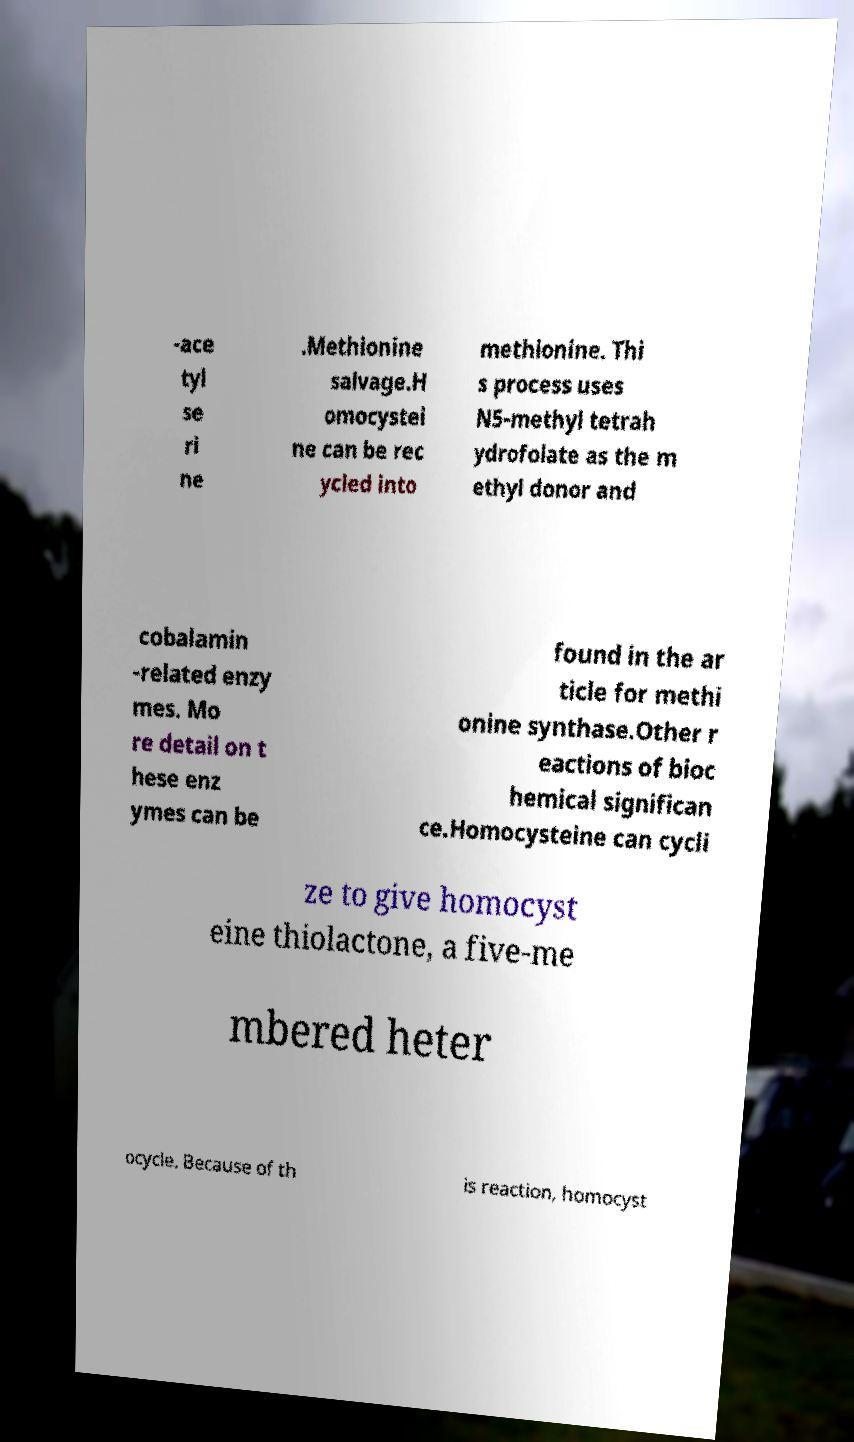Could you extract and type out the text from this image? -ace tyl se ri ne .Methionine salvage.H omocystei ne can be rec ycled into methionine. Thi s process uses N5-methyl tetrah ydrofolate as the m ethyl donor and cobalamin -related enzy mes. Mo re detail on t hese enz ymes can be found in the ar ticle for methi onine synthase.Other r eactions of bioc hemical significan ce.Homocysteine can cycli ze to give homocyst eine thiolactone, a five-me mbered heter ocycle. Because of th is reaction, homocyst 